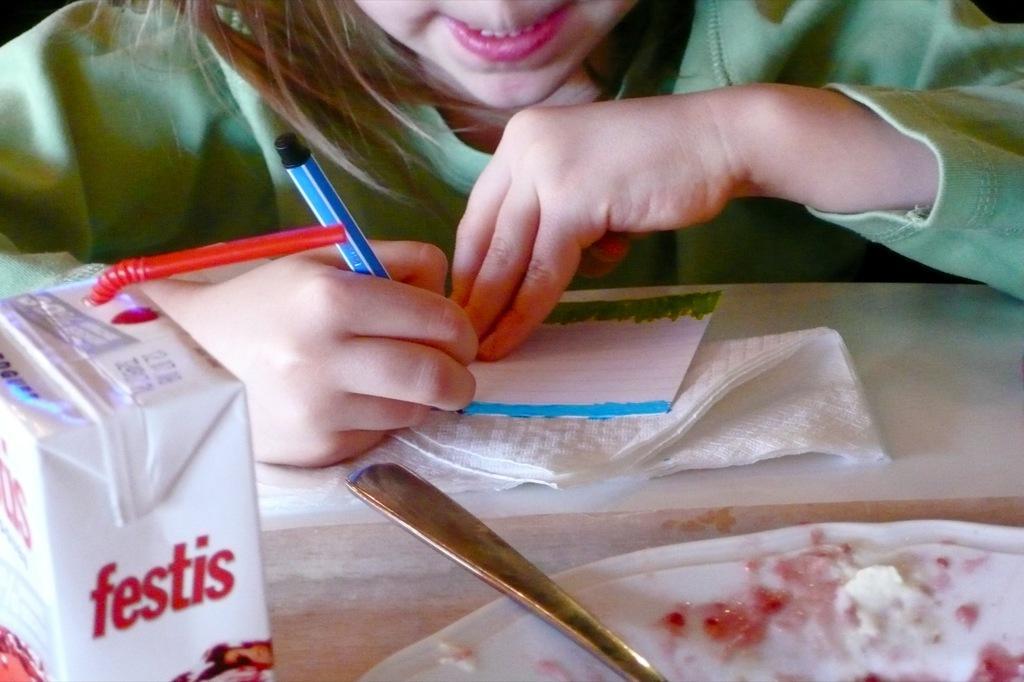Describe this image in one or two sentences. In this image there is a girl holding a pen and writing something on the paper, there is a table, on the table there are some food item and a spoon on the plate, a tissue paper and an object. 